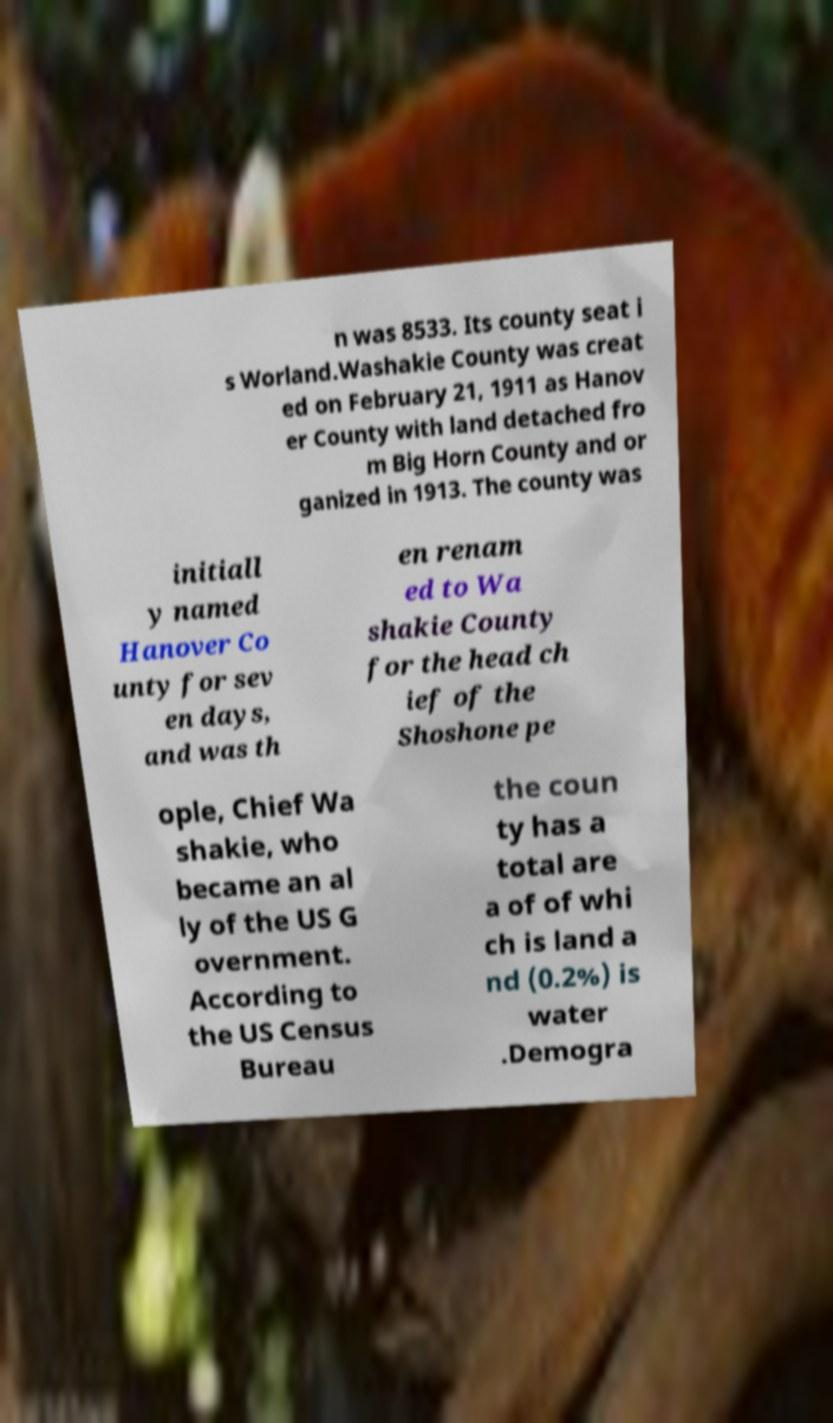Could you extract and type out the text from this image? n was 8533. Its county seat i s Worland.Washakie County was creat ed on February 21, 1911 as Hanov er County with land detached fro m Big Horn County and or ganized in 1913. The county was initiall y named Hanover Co unty for sev en days, and was th en renam ed to Wa shakie County for the head ch ief of the Shoshone pe ople, Chief Wa shakie, who became an al ly of the US G overnment. According to the US Census Bureau the coun ty has a total are a of of whi ch is land a nd (0.2%) is water .Demogra 